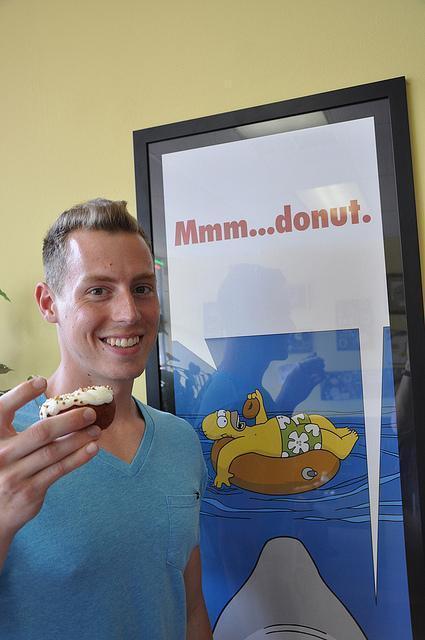How many eyes are there?
Give a very brief answer. 4. How many people are visible?
Give a very brief answer. 1. How many remotes do you see?
Give a very brief answer. 0. 